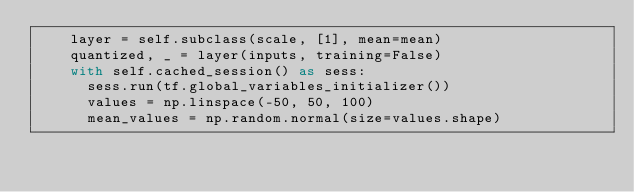<code> <loc_0><loc_0><loc_500><loc_500><_Python_>    layer = self.subclass(scale, [1], mean=mean)
    quantized, _ = layer(inputs, training=False)
    with self.cached_session() as sess:
      sess.run(tf.global_variables_initializer())
      values = np.linspace(-50, 50, 100)
      mean_values = np.random.normal(size=values.shape)</code> 